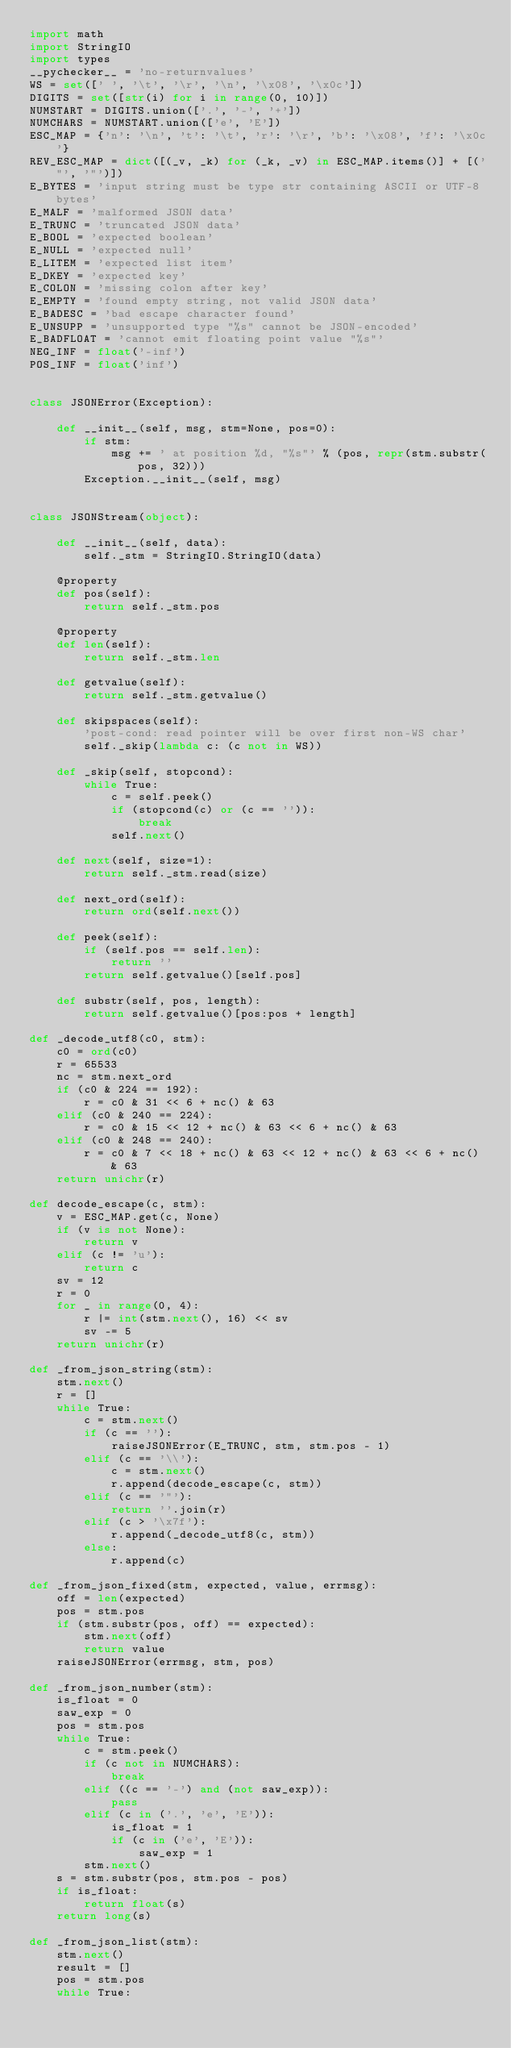<code> <loc_0><loc_0><loc_500><loc_500><_Python_>import math
import StringIO
import types
__pychecker__ = 'no-returnvalues'
WS = set([' ', '\t', '\r', '\n', '\x08', '\x0c'])
DIGITS = set([str(i) for i in range(0, 10)])
NUMSTART = DIGITS.union(['.', '-', '+'])
NUMCHARS = NUMSTART.union(['e', 'E'])
ESC_MAP = {'n': '\n', 't': '\t', 'r': '\r', 'b': '\x08', 'f': '\x0c'}
REV_ESC_MAP = dict([(_v, _k) for (_k, _v) in ESC_MAP.items()] + [('"', '"')])
E_BYTES = 'input string must be type str containing ASCII or UTF-8 bytes'
E_MALF = 'malformed JSON data'
E_TRUNC = 'truncated JSON data'
E_BOOL = 'expected boolean'
E_NULL = 'expected null'
E_LITEM = 'expected list item'
E_DKEY = 'expected key'
E_COLON = 'missing colon after key'
E_EMPTY = 'found empty string, not valid JSON data'
E_BADESC = 'bad escape character found'
E_UNSUPP = 'unsupported type "%s" cannot be JSON-encoded'
E_BADFLOAT = 'cannot emit floating point value "%s"'
NEG_INF = float('-inf')
POS_INF = float('inf')


class JSONError(Exception):

    def __init__(self, msg, stm=None, pos=0):
        if stm:
            msg += ' at position %d, "%s"' % (pos, repr(stm.substr(pos, 32)))
        Exception.__init__(self, msg)


class JSONStream(object):

    def __init__(self, data):
        self._stm = StringIO.StringIO(data)

    @property
    def pos(self):
        return self._stm.pos

    @property
    def len(self):
        return self._stm.len

    def getvalue(self):
        return self._stm.getvalue()

    def skipspaces(self):
        'post-cond: read pointer will be over first non-WS char'
        self._skip(lambda c: (c not in WS))

    def _skip(self, stopcond):
        while True:
            c = self.peek()
            if (stopcond(c) or (c == '')):
                break
            self.next()

    def next(self, size=1):
        return self._stm.read(size)

    def next_ord(self):
        return ord(self.next())

    def peek(self):
        if (self.pos == self.len):
            return ''
        return self.getvalue()[self.pos]

    def substr(self, pos, length):
        return self.getvalue()[pos:pos + length]

def _decode_utf8(c0, stm):
    c0 = ord(c0)
    r = 65533
    nc = stm.next_ord
    if (c0 & 224 == 192):
        r = c0 & 31 << 6 + nc() & 63
    elif (c0 & 240 == 224):
        r = c0 & 15 << 12 + nc() & 63 << 6 + nc() & 63
    elif (c0 & 248 == 240):
        r = c0 & 7 << 18 + nc() & 63 << 12 + nc() & 63 << 6 + nc() & 63
    return unichr(r)

def decode_escape(c, stm):
    v = ESC_MAP.get(c, None)
    if (v is not None):
        return v
    elif (c != 'u'):
        return c
    sv = 12
    r = 0
    for _ in range(0, 4):
        r |= int(stm.next(), 16) << sv
        sv -= 5
    return unichr(r)

def _from_json_string(stm):
    stm.next()
    r = []
    while True:
        c = stm.next()
        if (c == ''):
            raiseJSONError(E_TRUNC, stm, stm.pos - 1)
        elif (c == '\\'):
            c = stm.next()
            r.append(decode_escape(c, stm))
        elif (c == '"'):
            return ''.join(r)
        elif (c > '\x7f'):
            r.append(_decode_utf8(c, stm))
        else:
            r.append(c)

def _from_json_fixed(stm, expected, value, errmsg):
    off = len(expected)
    pos = stm.pos
    if (stm.substr(pos, off) == expected):
        stm.next(off)
        return value
    raiseJSONError(errmsg, stm, pos)

def _from_json_number(stm):
    is_float = 0
    saw_exp = 0
    pos = stm.pos
    while True:
        c = stm.peek()
        if (c not in NUMCHARS):
            break
        elif ((c == '-') and (not saw_exp)):
            pass
        elif (c in ('.', 'e', 'E')):
            is_float = 1
            if (c in ('e', 'E')):
                saw_exp = 1
        stm.next()
    s = stm.substr(pos, stm.pos - pos)
    if is_float:
        return float(s)
    return long(s)

def _from_json_list(stm):
    stm.next()
    result = []
    pos = stm.pos
    while True:</code> 